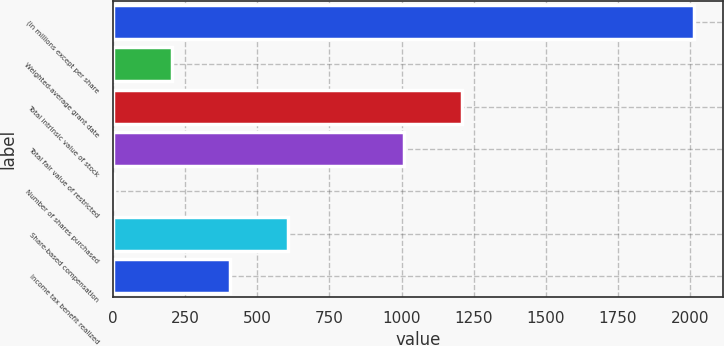Convert chart. <chart><loc_0><loc_0><loc_500><loc_500><bar_chart><fcel>(in millions except per share<fcel>Weighted-average grant date<fcel>Total intrinsic value of stock<fcel>Total fair value of restricted<fcel>Number of shares purchased<fcel>Share-based compensation<fcel>Income tax benefit realized<nl><fcel>2015<fcel>203.3<fcel>1209.8<fcel>1008.5<fcel>2<fcel>605.9<fcel>404.6<nl></chart> 